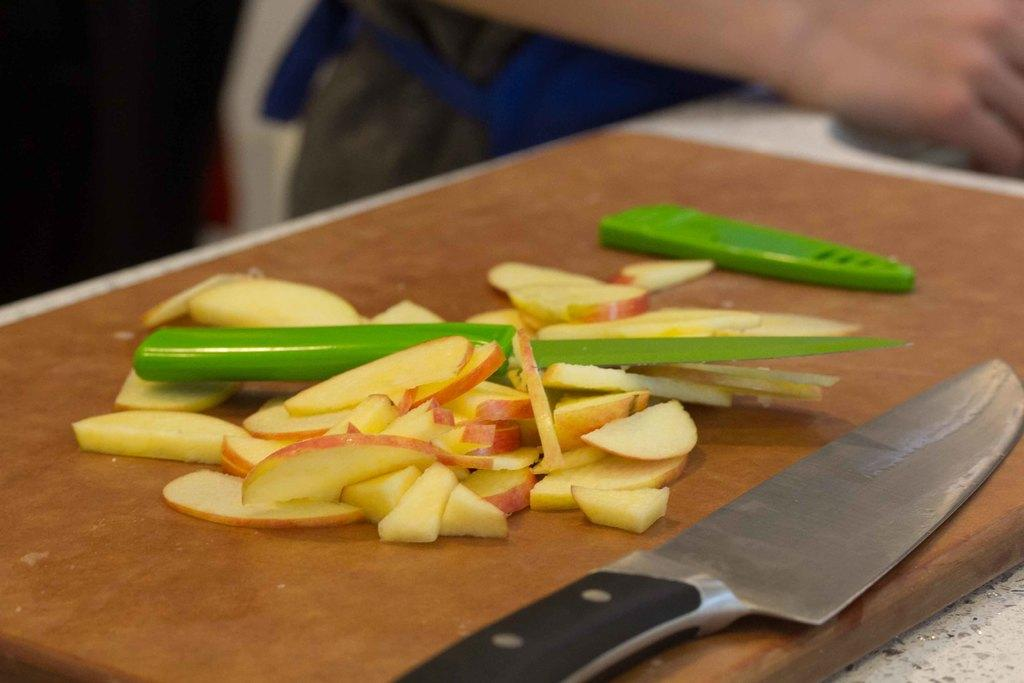What type of fruit is visible in the image? There are pieces of an apple in the image. What object is used for cutting in the image? A knife is present on a chop board in the image. Can you describe the person in the image? There is a person at the top of the image. What type of experience does the wall have in the image? There is no wall present in the image, so it is not possible to discuss the experience of a wall. 